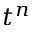Convert formula to latex. <formula><loc_0><loc_0><loc_500><loc_500>t ^ { n }</formula> 